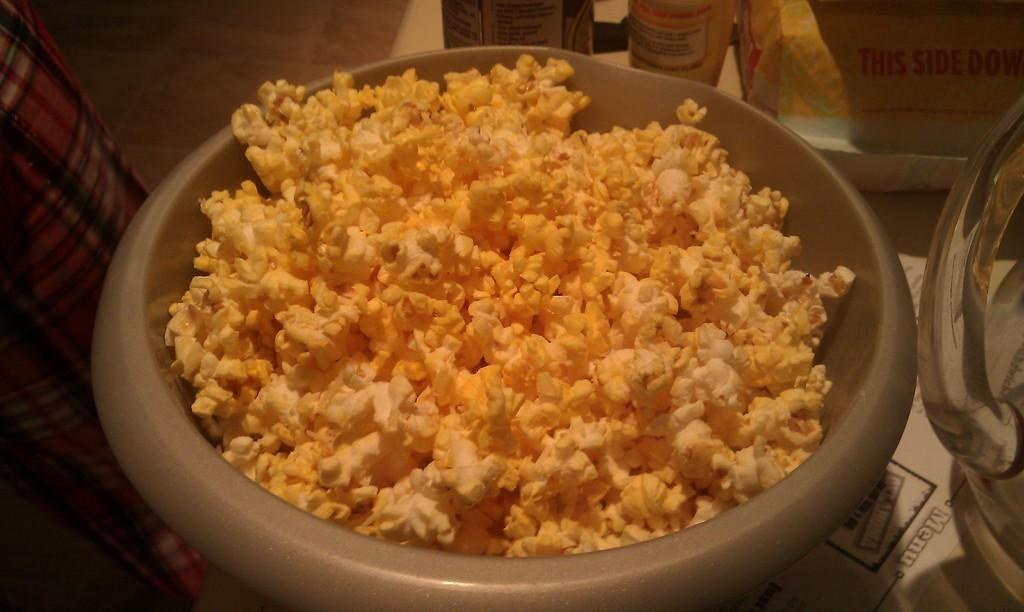What is in the bowl that is visible in the image? There is a bowl with popcorn in the image. What color is the bowl in the image? The bowl is grey in color. What other item can be seen in the image besides the bowl? There is a glass water jar in the image. How many goldfish are swimming in the bowl with popcorn? There are no goldfish present in the image; the bowl contains popcorn. 